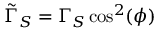<formula> <loc_0><loc_0><loc_500><loc_500>\tilde { \Gamma } _ { S } = \Gamma _ { S } \cos ^ { 2 } ( \phi )</formula> 